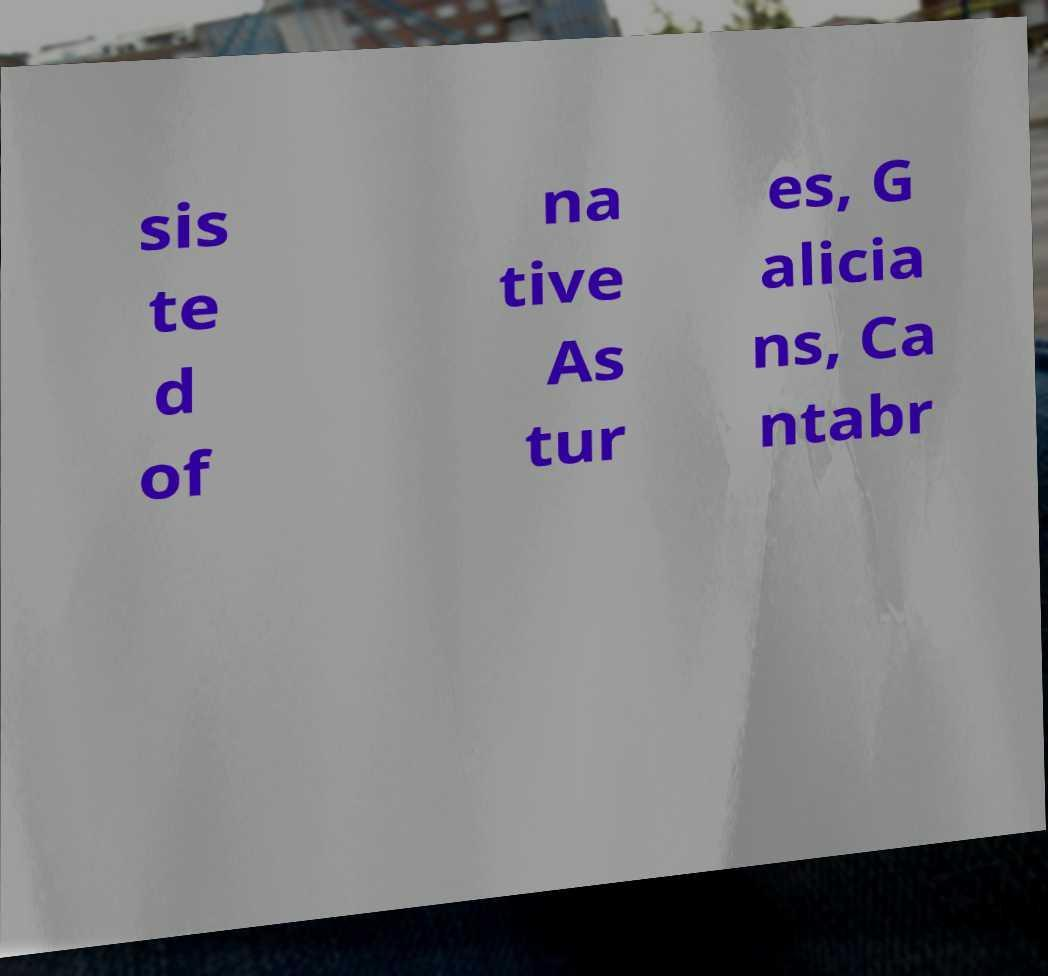For documentation purposes, I need the text within this image transcribed. Could you provide that? sis te d of na tive As tur es, G alicia ns, Ca ntabr 